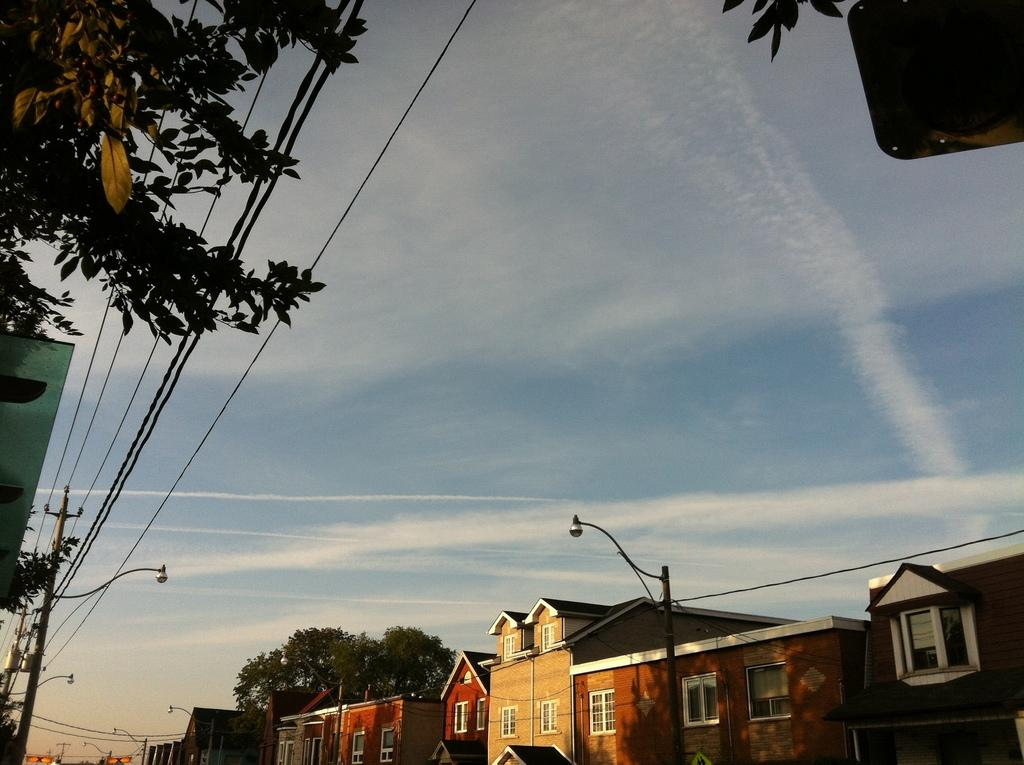What type of structures can be seen in the image? There are buildings in the image. What natural elements are present in the image? There are trees in the image. What type of infrastructure can be seen in the image? There are poles with wires and street lights in the image. What is visible in the background of the image? The sky is visible in the background of the image. What type of knee injury can be seen in the image? There is no knee injury present in the image. How much sugar is visible in the image? There is no sugar visible in the image. 